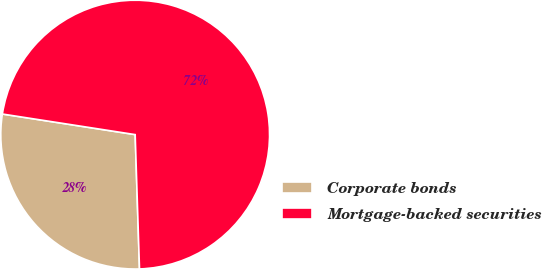<chart> <loc_0><loc_0><loc_500><loc_500><pie_chart><fcel>Corporate bonds<fcel>Mortgage-backed securities<nl><fcel>27.96%<fcel>72.04%<nl></chart> 